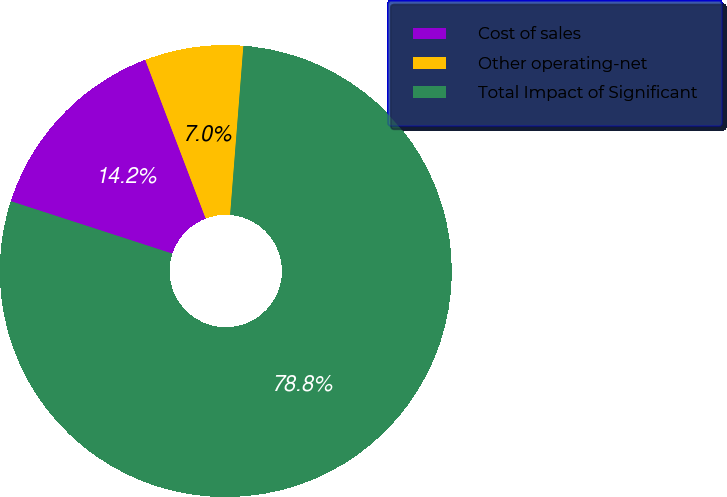Convert chart to OTSL. <chart><loc_0><loc_0><loc_500><loc_500><pie_chart><fcel>Cost of sales<fcel>Other operating-net<fcel>Total Impact of Significant<nl><fcel>14.21%<fcel>7.04%<fcel>78.75%<nl></chart> 